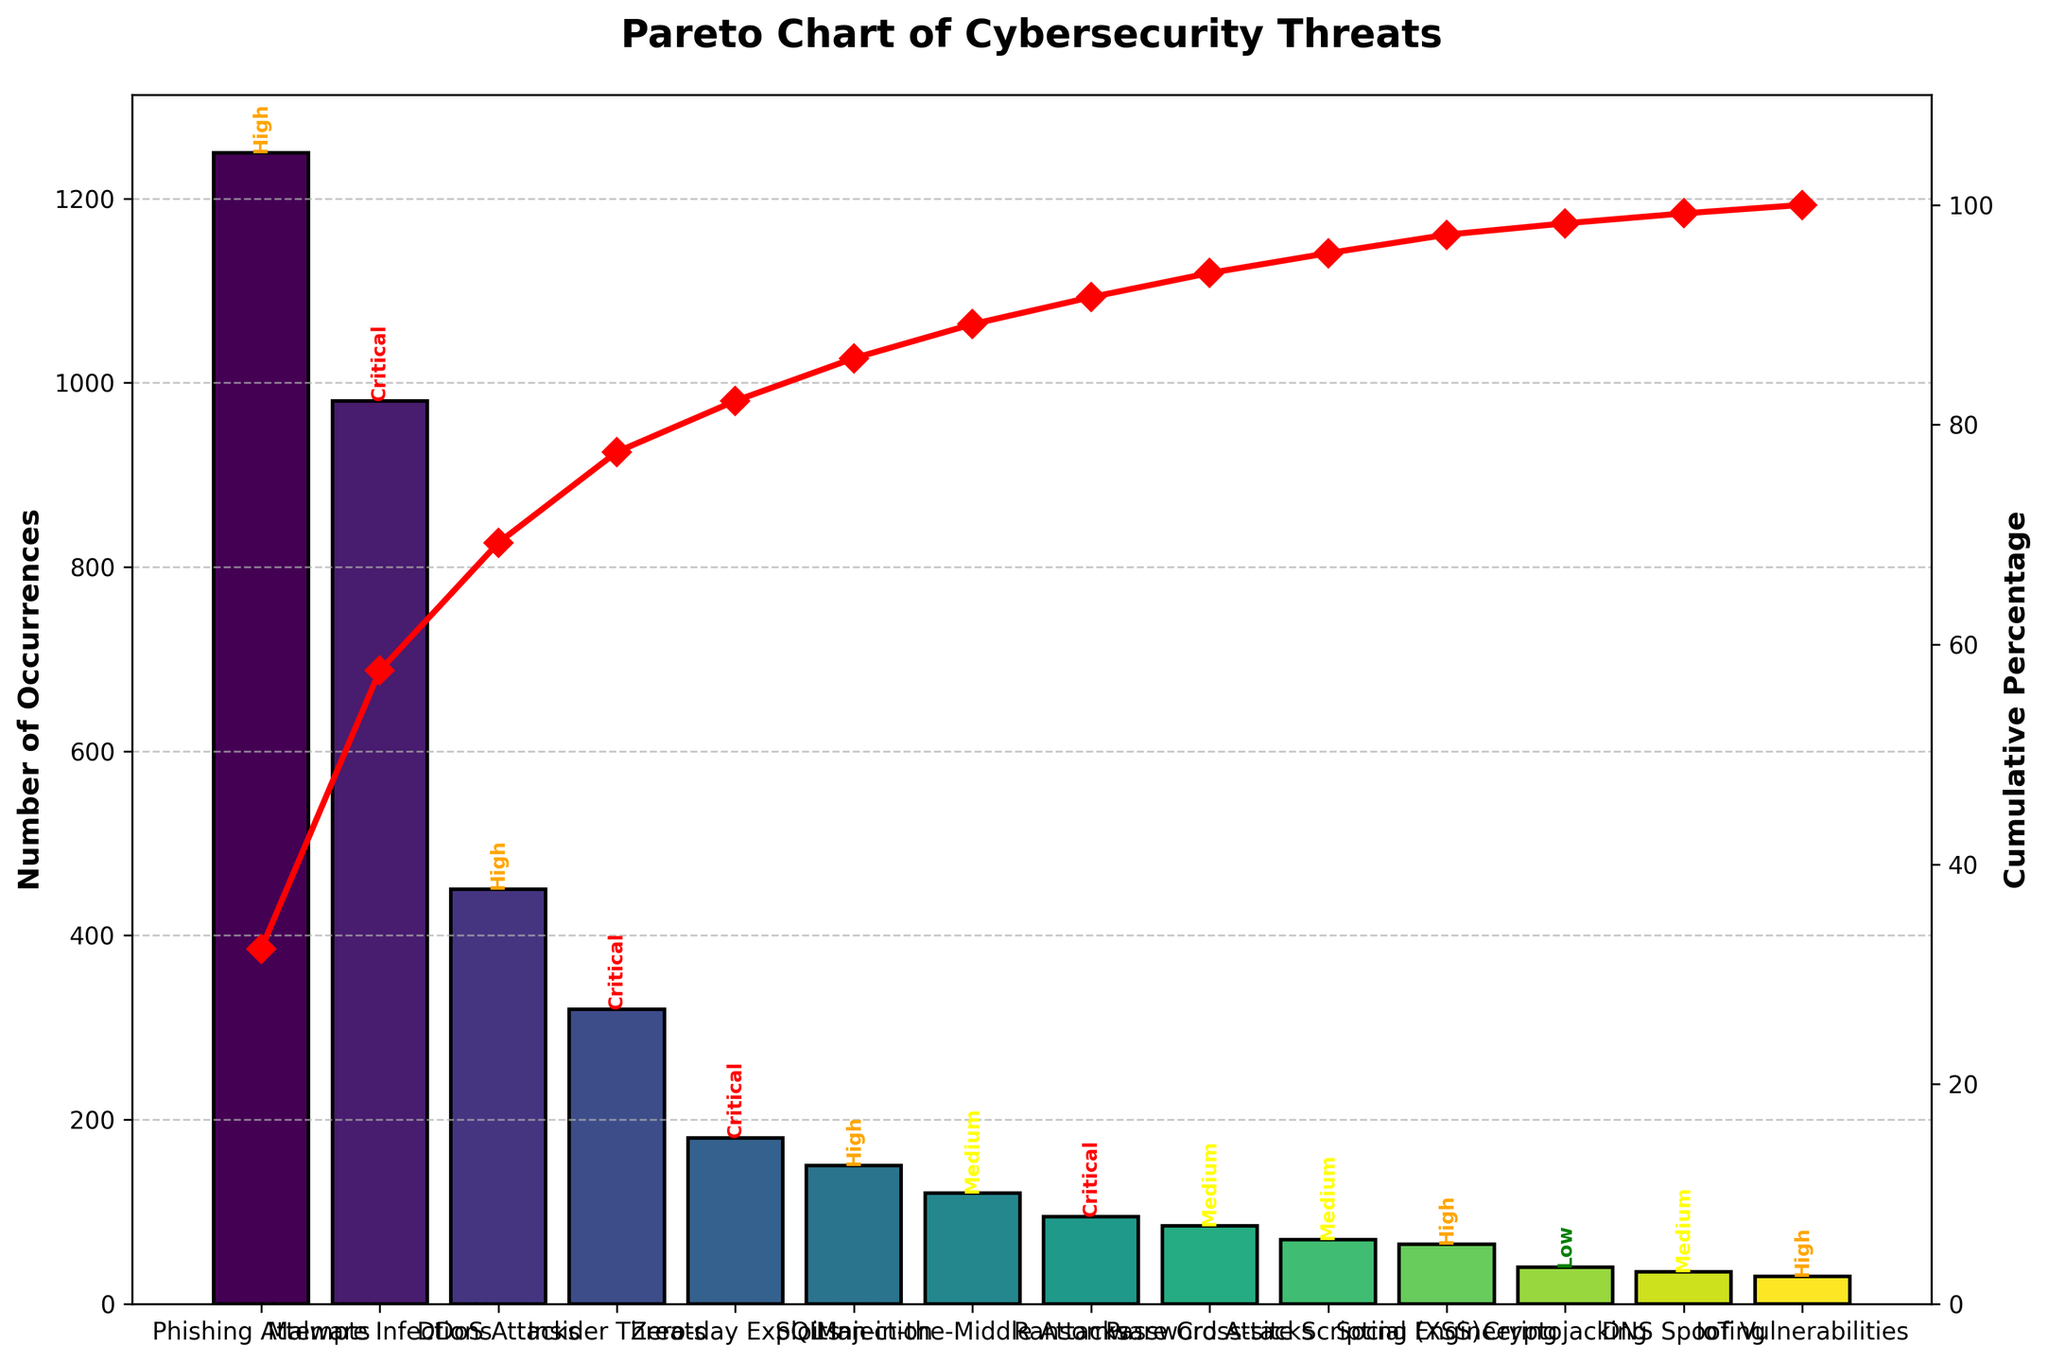what is the title of the figure? The title is located at the top of the chart. Reading it directly, we can see that it states, "Pareto Chart of Cybersecurity Threats."
Answer: Pareto Chart of Cybersecurity Threats How many threat types are categorized as "Critical" severity? To determine this, we look at the bars with the text label "Critical" which are colored red. There are 4 such bars: Malware Infections, Insider Threats, Zero-day Exploits, and Ransomware.
Answer: 4 Which threat type has the highest number of occurrences? By examining the heights of the bars, the tallest bar represents the threat type with the highest occurrences. It is labeled "Phishing Attempts" with 1250 occurrences.
Answer: Phishing Attempts What is the cumulative percentage for the top three threat types? We find the top three threat types based on bar height: Phishing Attempts, Malware Infections, and DDoS Attacks. Their cumulative percentage can be read off the secondary y-axis where the red line intersects. It is approximately 72%.
Answer: 72% Compare the occurrences of "SQL Injection" and "Social Engineering" threats. Which one is higher? "SQL Injection" has 150 occurrences, while "Social Engineering" has 65 occurrences. Comparing these values, "SQL Injection" has higher occurrences.
Answer: SQL Injection What threat type contributes to the 50% cumulative percentage mark on the Pareto chart? By tracing from the 50% mark on the secondary y-axis to where it intersects the red cumulative line, we see it lines up with "DDoS Attacks."
Answer: DDoS Attacks What is the sum of occurrences for all threat types classified as "High" severity? The "High" severity threats are Phishing Attempts (1250), DDoS Attacks (450), SQL Injection (150), Social Engineering (65), and IoT Vulnerabilities (30). Summing these values: 1250 + 450 + 150 + 65 + 30 = 1945.
Answer: 1945 Which threat type has the lowest number of occurrences and what is the severity level? By identifying the shortest bar, it represents "IoT Vulnerabilities" with 30 occurrences, labeled as "High" severity.
Answer: IoT Vulnerabilities, High What is the difference in the number of occurrences between "Man-in-the-Middle Attacks" and "Cryptojacking"? "Man-in-the-Middle Attacks" have 120 occurrences and "Cryptojacking" has 40 occurrences. The difference is 120 - 40 = 80.
Answer: 80 